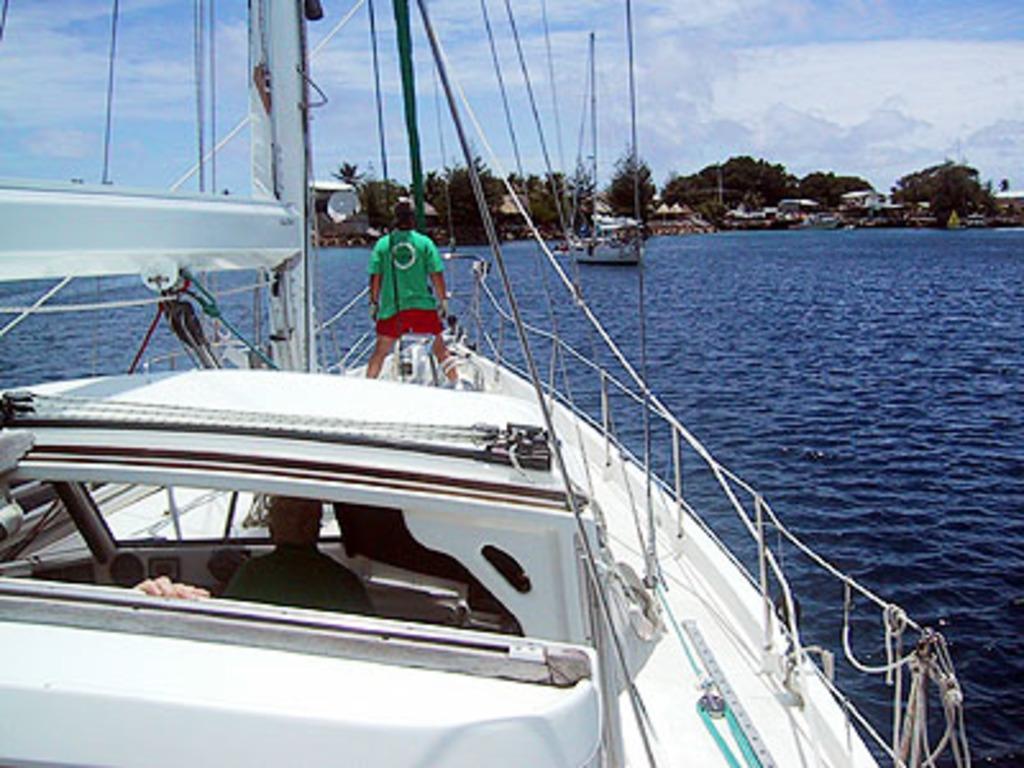Please provide a concise description of this image. In the image in the center, we can see one boat. On the boat, we can see two persons. In the background, we can see the sky, clouds, trees, buildings, water and one boat. 